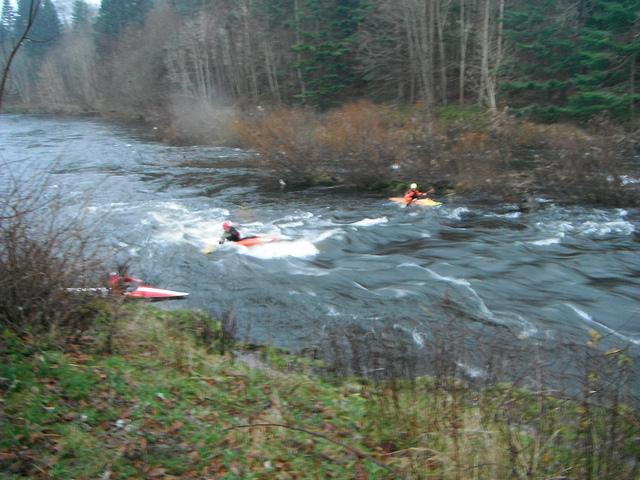What are the people doing?
Be succinct. Kayaking. How can you tell if the water is moving?
Short answer required. Waves. Who is in the water?
Quick response, please. Kayakers. 